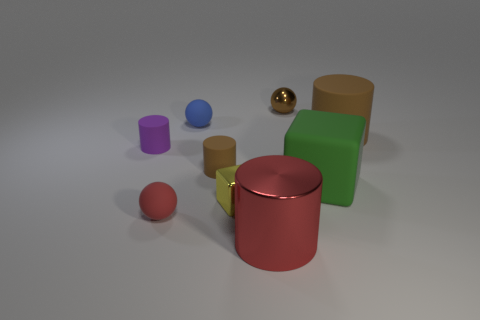Add 1 tiny gray cubes. How many objects exist? 10 Subtract all balls. How many objects are left? 6 Add 5 big green matte things. How many big green matte things exist? 6 Subtract 0 gray cubes. How many objects are left? 9 Subtract all blue matte things. Subtract all brown spheres. How many objects are left? 7 Add 5 blue spheres. How many blue spheres are left? 6 